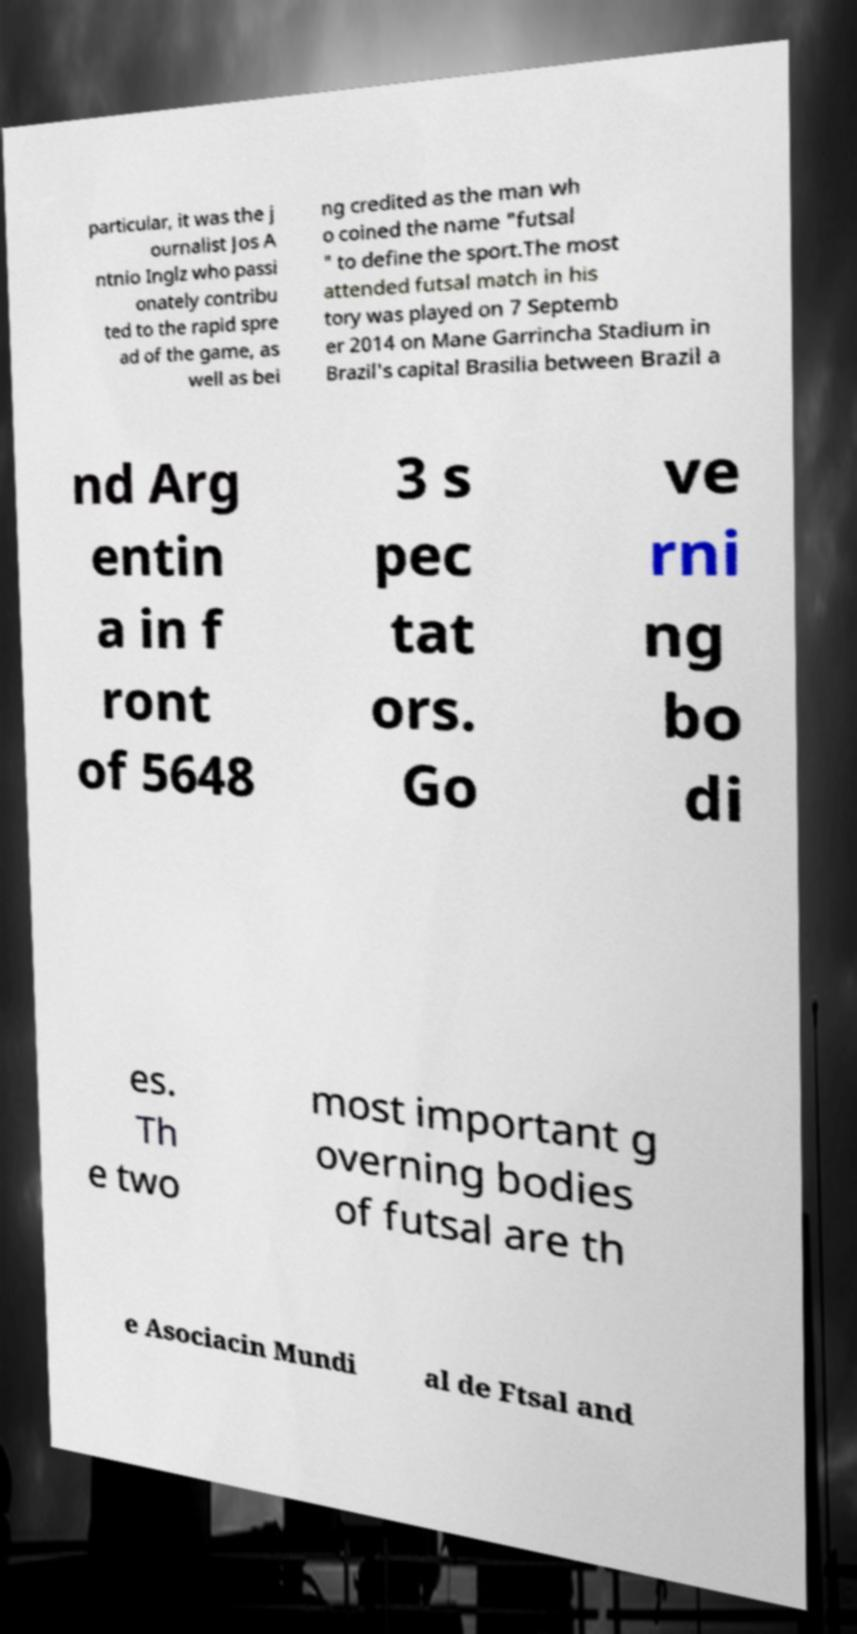Could you assist in decoding the text presented in this image and type it out clearly? particular, it was the j ournalist Jos A ntnio Inglz who passi onately contribu ted to the rapid spre ad of the game, as well as bei ng credited as the man wh o coined the name "futsal " to define the sport.The most attended futsal match in his tory was played on 7 Septemb er 2014 on Mane Garrincha Stadium in Brazil's capital Brasilia between Brazil a nd Arg entin a in f ront of 5648 3 s pec tat ors. Go ve rni ng bo di es. Th e two most important g overning bodies of futsal are th e Asociacin Mundi al de Ftsal and 